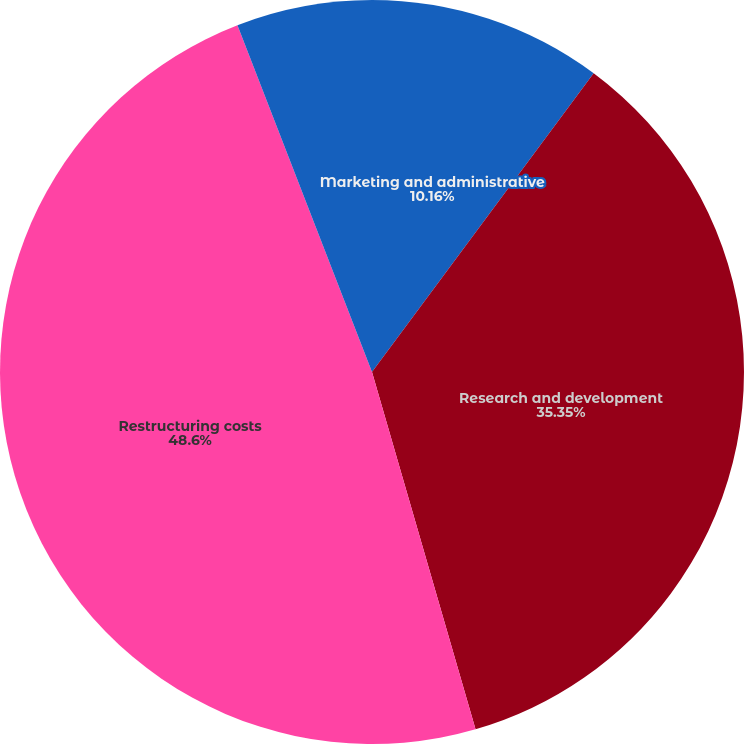<chart> <loc_0><loc_0><loc_500><loc_500><pie_chart><fcel>Marketing and administrative<fcel>Research and development<fcel>Restructuring costs<fcel>Equity income from affiliates<nl><fcel>10.16%<fcel>35.35%<fcel>48.6%<fcel>5.89%<nl></chart> 